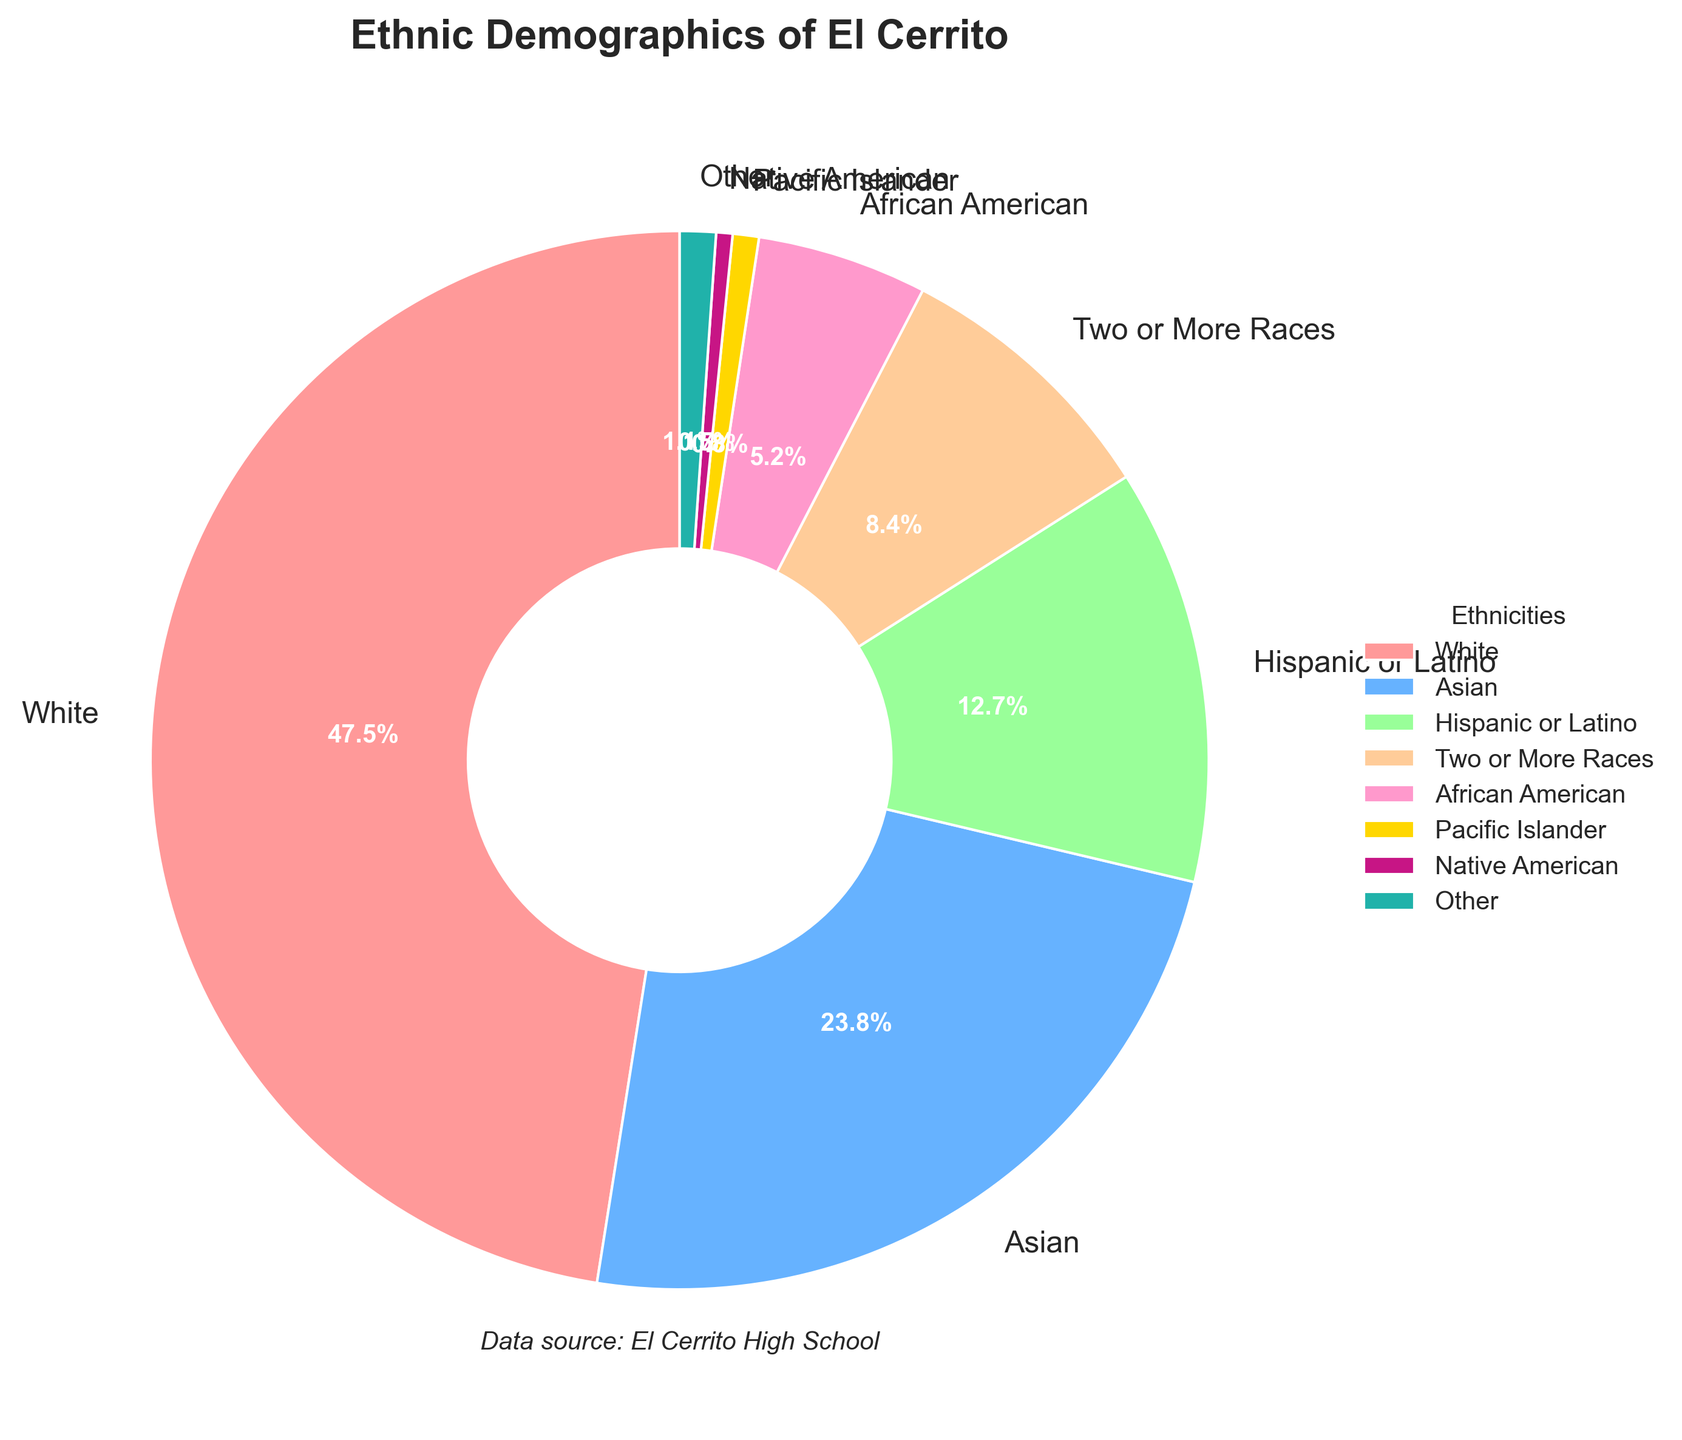What is the combined percentage of 'White' and 'Asian' ethnic groups? To find the combined percentage, add the percentage of the 'White' group to the percentage of the 'Asian' group. The 'White' group has 47.5% and the 'Asian' group has 23.8%. So, 47.5 + 23.8 = 71.3%.
Answer: 71.3% Which ethnic group has the smallest representation? To identify the ethnic group with the smallest representation, look at the pie chart's data labels. The 'Native American' group has the smallest percentage at 0.5%.
Answer: Native American How much larger is the 'White' population compared to the 'African American' population? To find how much larger the 'White' population is compared to the 'African American' population, subtract the percentage of the 'African American' group from the percentage of the 'White' group. 47.5% (White) - 5.2% (African American) = 42.3%.
Answer: 42.3% What color represents the 'Hispanic or Latino' group in the pie chart? To determine the color representing the 'Hispanic or Latino' group, identify it in the pie chart's legend. The color for the 'Hispanic or Latino' group is shown as a pale yellow or gold.
Answer: pale yellow/gold Is the percentage of 'Two or More Races' greater than the percentage of 'African American'? To compare the percentages, look at the data labels. 'Two or More Races' has 8.4%, and 'African American' has 5.2%. Since 8.4% is greater than 5.2%, the answer is yes.
Answer: Yes What is the percentage of the three smallest ethnic groups combined? To find the combined percentage of the three smallest groups ('Native American', 'Pacific Islander', and 'Other'), add their percentages: 0.5% (Native American) + 0.8% (Pacific Islander) + 1.1% (Other) = 2.4%.
Answer: 2.4% What percentage more is the 'Asian' group than the 'Hispanic or Latino' group? To find the percentage more, subtract the 'Hispanic or Latino' percentage from the 'Asian' percentage and divide by the 'Hispanic or Latino' percentage, then multiply by 100. (23.8% - 12.7%) / 12.7% * 100 = 87.4%
Answer: 87.4% List the ethnic groups whose percentages are less than 10%. Look at the data and identify the groups with percentages less than 10%. These are: 'Two or More Races' (8.4%), 'African American' (5.2%), 'Pacific Islander' (0.8%), 'Native American' (0.5%), and 'Other' (1.1%).
Answer: Two or More Races, African American, Pacific Islander, Native American, Other Which ethnic group has a representation closest to 25%? Examine the percentages and identify the group closest to 25%. The 'Asian' group has 23.8%, which is closest to 25%.
Answer: Asian 